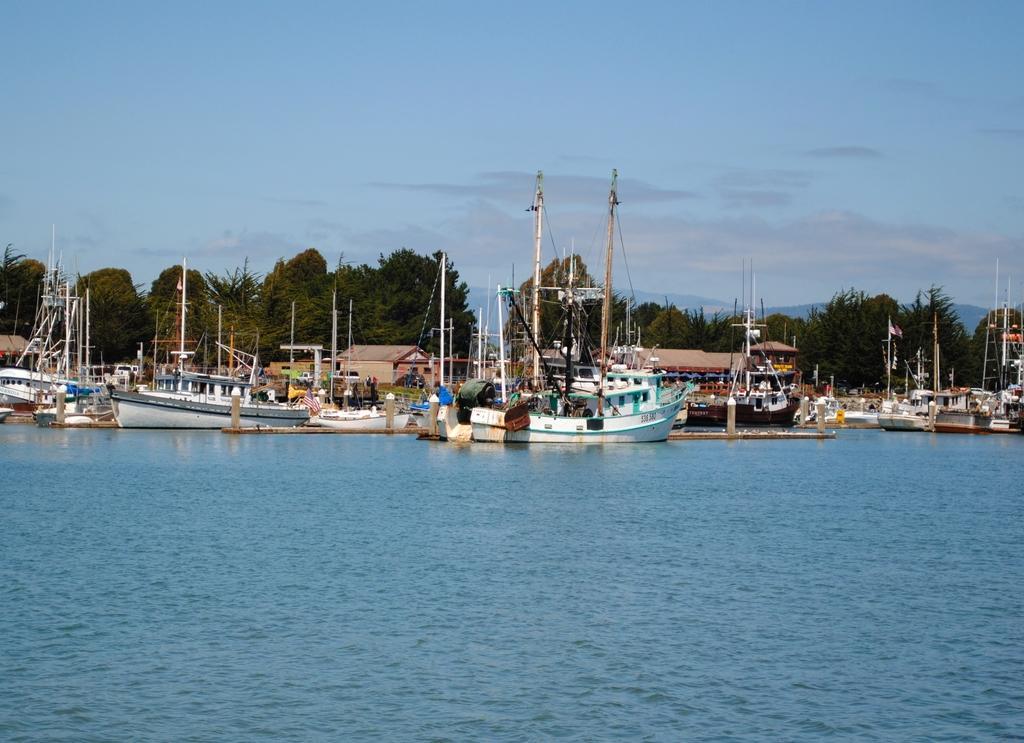How would you summarize this image in a sentence or two? In this image I can see the water. I can see the ships. In the background, I can see the trees and clouds in the sky. 